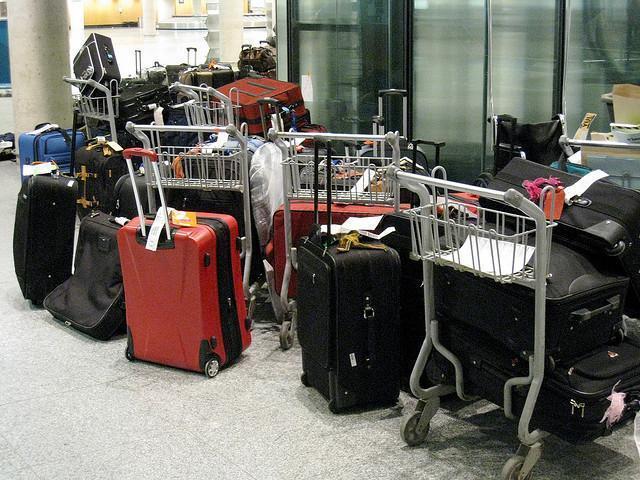How many suitcases are there?
Give a very brief answer. 11. How many red bikes are there?
Give a very brief answer. 0. 